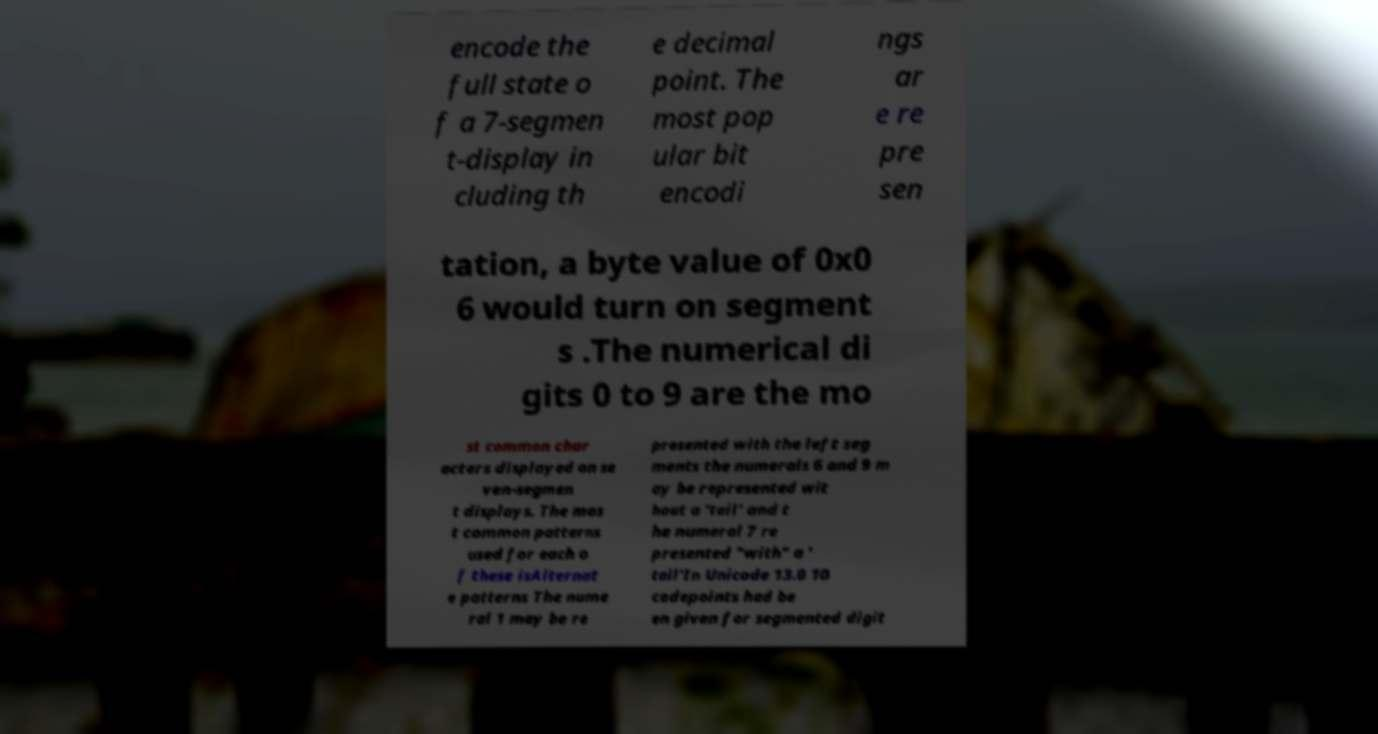Could you extract and type out the text from this image? encode the full state o f a 7-segmen t-display in cluding th e decimal point. The most pop ular bit encodi ngs ar e re pre sen tation, a byte value of 0x0 6 would turn on segment s .The numerical di gits 0 to 9 are the mo st common char acters displayed on se ven-segmen t displays. The mos t common patterns used for each o f these isAlternat e patterns The nume ral 1 may be re presented with the left seg ments the numerals 6 and 9 m ay be represented wit hout a 'tail' and t he numeral 7 re presented "with" a ' tail'In Unicode 13.0 10 codepoints had be en given for segmented digit 